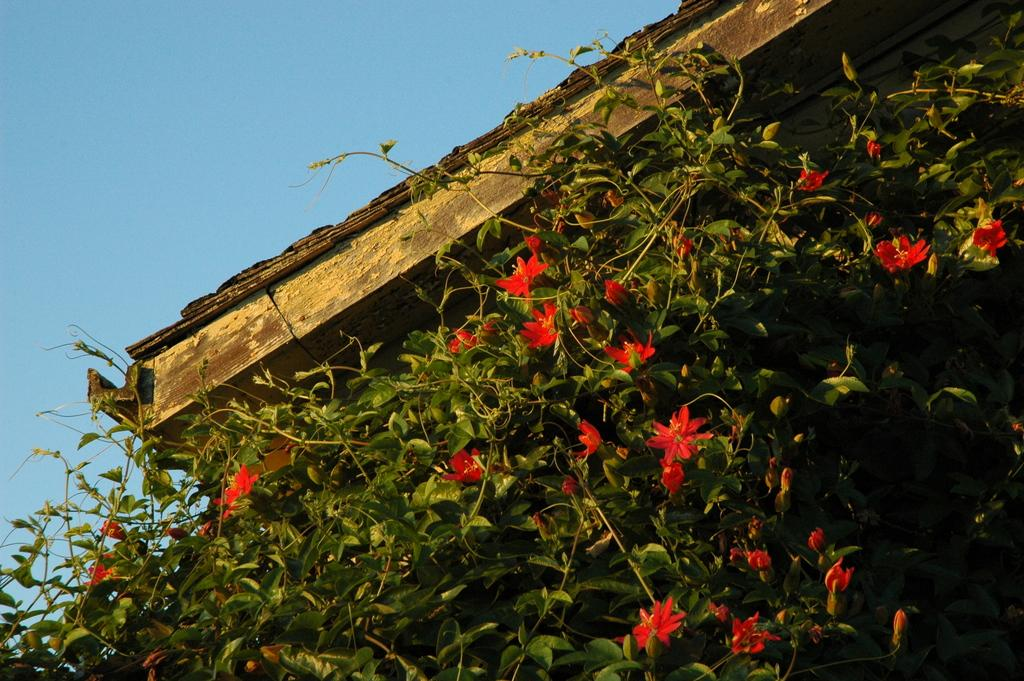What type of vegetation can be seen in the image? There are leaves and flowers in the image. What is visible at the top of the image? The sky is visible at the top of the image. What hobbies do the flowers have in the image? The flowers in the image do not have hobbies, as they are inanimate objects. 